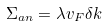<formula> <loc_0><loc_0><loc_500><loc_500>\Sigma _ { a n } = \lambda v _ { F } \delta k</formula> 